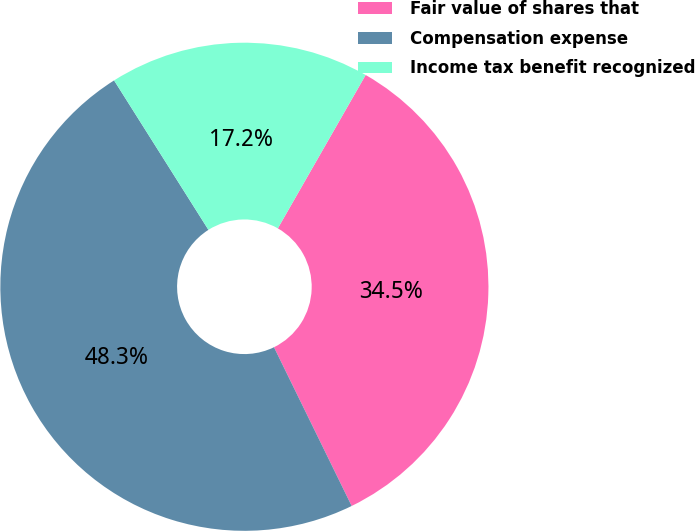<chart> <loc_0><loc_0><loc_500><loc_500><pie_chart><fcel>Fair value of shares that<fcel>Compensation expense<fcel>Income tax benefit recognized<nl><fcel>34.48%<fcel>48.28%<fcel>17.24%<nl></chart> 